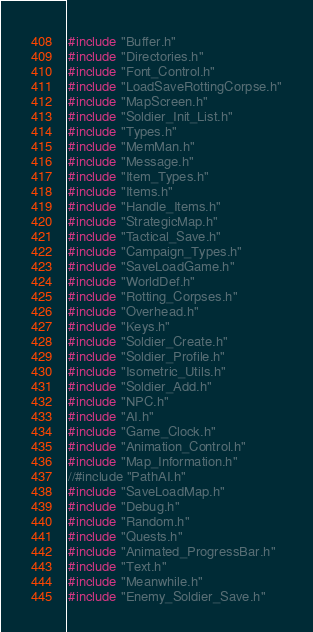Convert code to text. <code><loc_0><loc_0><loc_500><loc_500><_C++_>#include "Buffer.h"
#include "Directories.h"
#include "Font_Control.h"
#include "LoadSaveRottingCorpse.h"
#include "MapScreen.h"
#include "Soldier_Init_List.h"
#include "Types.h"
#include "MemMan.h"
#include "Message.h"
#include "Item_Types.h"
#include "Items.h"
#include "Handle_Items.h"
#include "StrategicMap.h"
#include "Tactical_Save.h"
#include "Campaign_Types.h"
#include "SaveLoadGame.h"
#include "WorldDef.h"
#include "Rotting_Corpses.h"
#include "Overhead.h"
#include "Keys.h"
#include "Soldier_Create.h"
#include "Soldier_Profile.h"
#include "Isometric_Utils.h"
#include "Soldier_Add.h"
#include "NPC.h"
#include "AI.h"
#include "Game_Clock.h"
#include "Animation_Control.h"
#include "Map_Information.h"
//#include "PathAI.h"
#include "SaveLoadMap.h"
#include "Debug.h"
#include "Random.h"
#include "Quests.h"
#include "Animated_ProgressBar.h"
#include "Text.h"
#include "Meanwhile.h"
#include "Enemy_Soldier_Save.h"</code> 